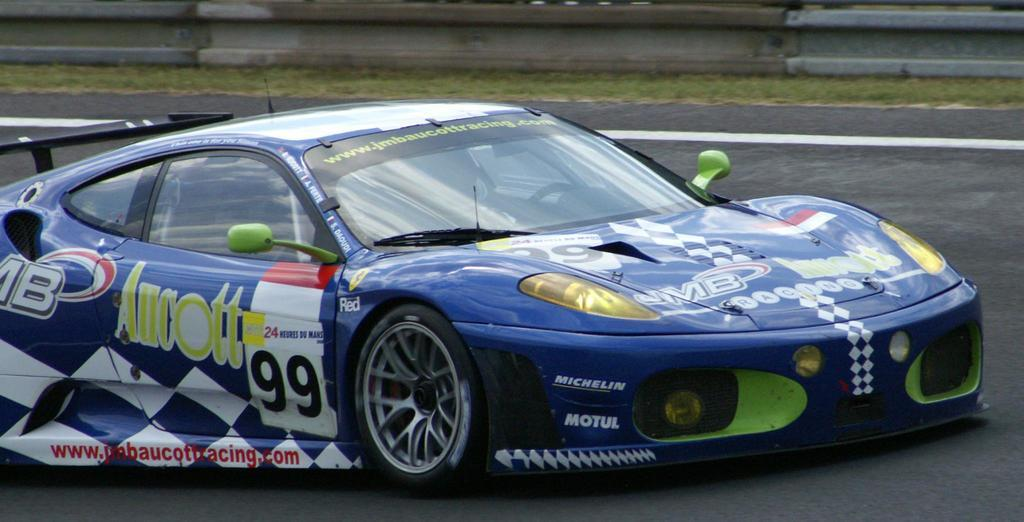What is the main subject of the image? There is a car in the center of the image. What is the car positioned on in the image? The car is on a road, which is visible at the bottom of the image. What type of natural environment can be seen in the background of the image? There is grass visible in the background of the image. Where is the dock located in the image? There is no dock present in the image. What type of war is being depicted in the image? There is no depiction of war in the image; it features a car on a road with grass in the background. 